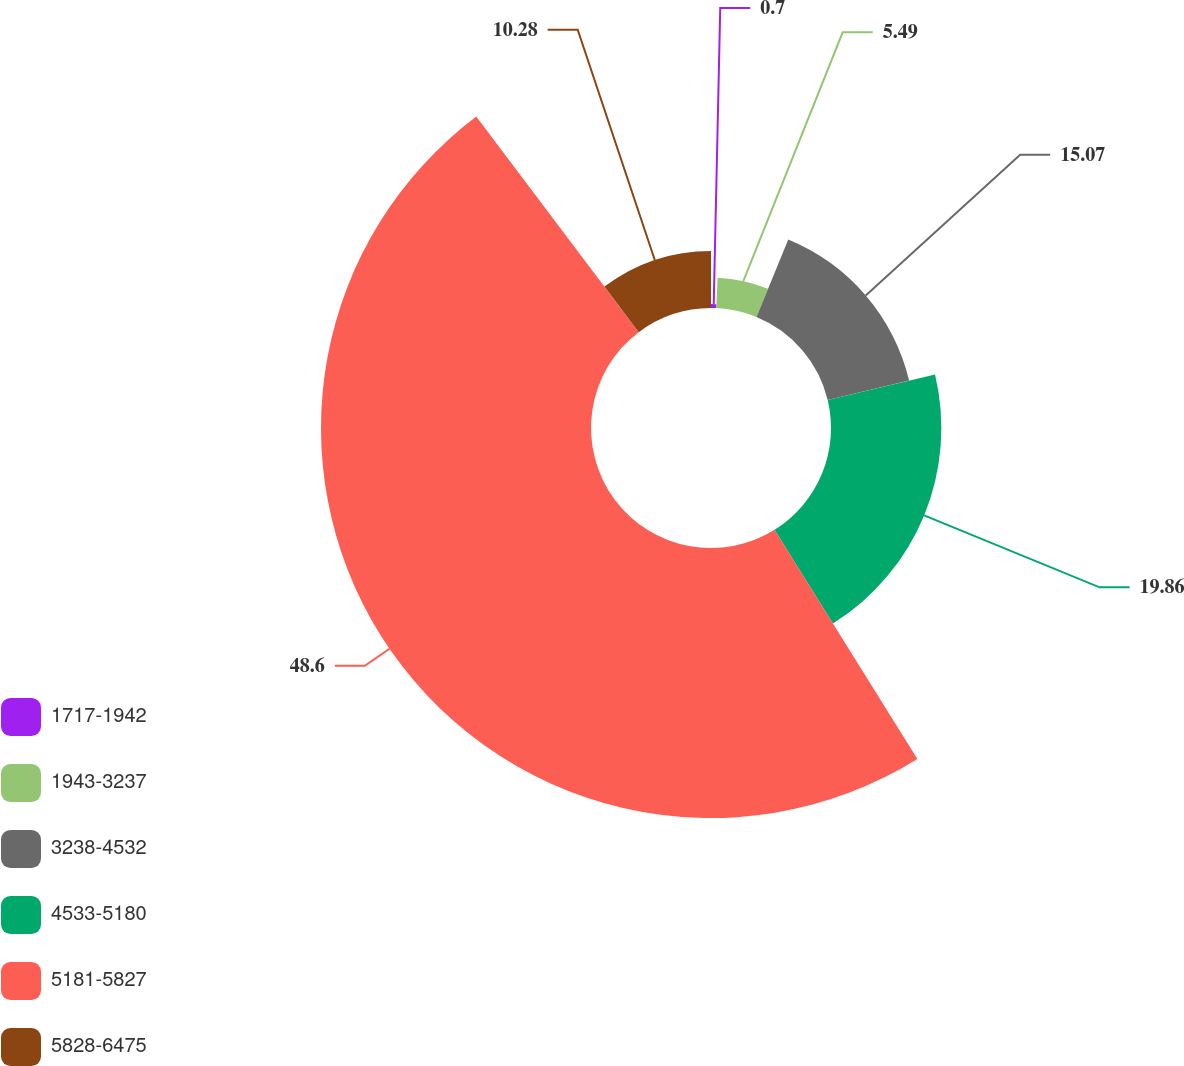Convert chart to OTSL. <chart><loc_0><loc_0><loc_500><loc_500><pie_chart><fcel>1717-1942<fcel>1943-3237<fcel>3238-4532<fcel>4533-5180<fcel>5181-5827<fcel>5828-6475<nl><fcel>0.7%<fcel>5.49%<fcel>15.07%<fcel>19.86%<fcel>48.59%<fcel>10.28%<nl></chart> 